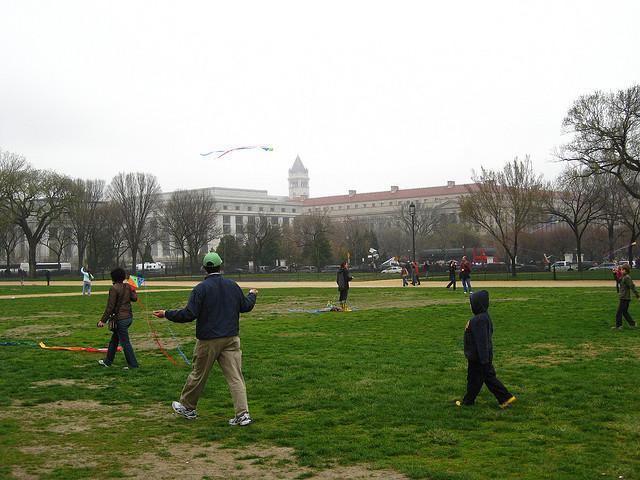How many people are there?
Give a very brief answer. 3. How many elephants are there?
Give a very brief answer. 0. 